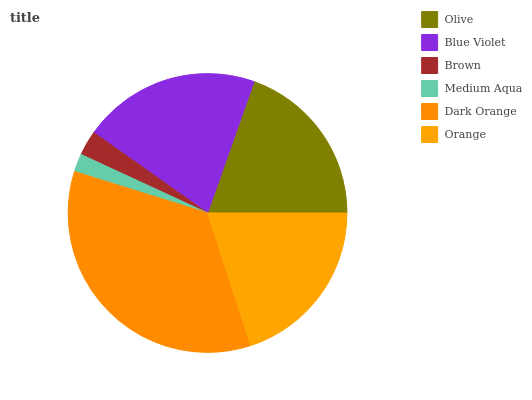Is Medium Aqua the minimum?
Answer yes or no. Yes. Is Dark Orange the maximum?
Answer yes or no. Yes. Is Blue Violet the minimum?
Answer yes or no. No. Is Blue Violet the maximum?
Answer yes or no. No. Is Blue Violet greater than Olive?
Answer yes or no. Yes. Is Olive less than Blue Violet?
Answer yes or no. Yes. Is Olive greater than Blue Violet?
Answer yes or no. No. Is Blue Violet less than Olive?
Answer yes or no. No. Is Orange the high median?
Answer yes or no. Yes. Is Olive the low median?
Answer yes or no. Yes. Is Brown the high median?
Answer yes or no. No. Is Brown the low median?
Answer yes or no. No. 